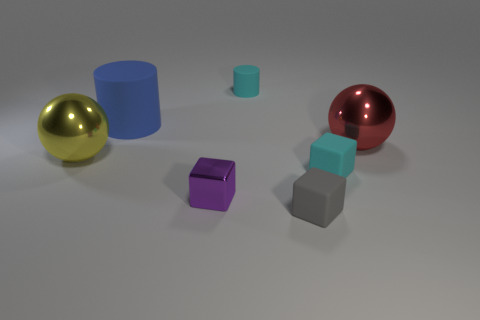Subtract all matte blocks. How many blocks are left? 1 Subtract 1 cubes. How many cubes are left? 2 Add 2 big blue rubber cylinders. How many objects exist? 9 Subtract all spheres. How many objects are left? 5 Subtract all big yellow balls. Subtract all small cyan cylinders. How many objects are left? 5 Add 7 red metallic spheres. How many red metallic spheres are left? 8 Add 7 yellow metallic things. How many yellow metallic things exist? 8 Subtract 0 red cylinders. How many objects are left? 7 Subtract all blue blocks. Subtract all green balls. How many blocks are left? 3 